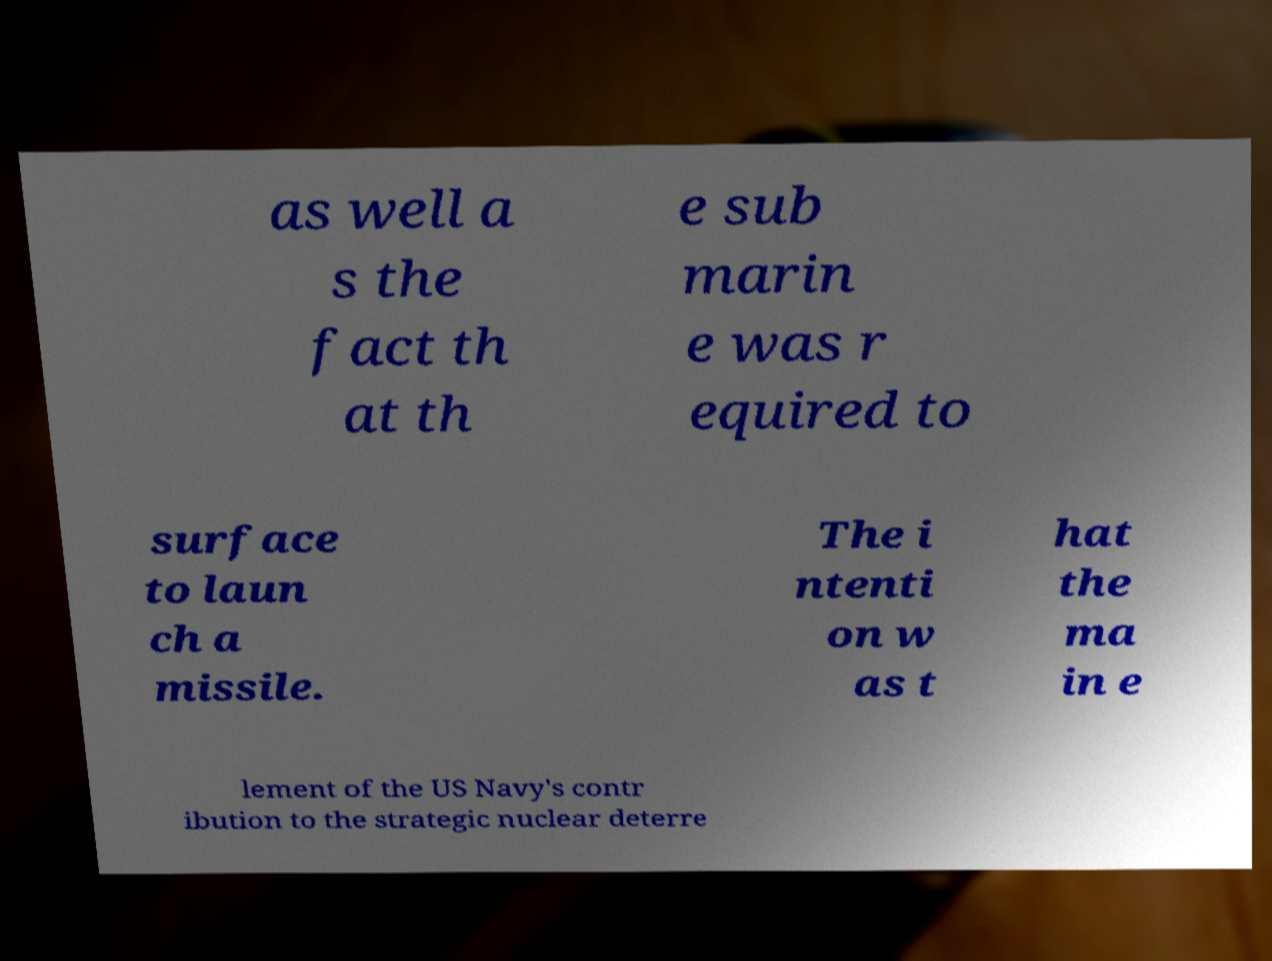Can you accurately transcribe the text from the provided image for me? as well a s the fact th at th e sub marin e was r equired to surface to laun ch a missile. The i ntenti on w as t hat the ma in e lement of the US Navy's contr ibution to the strategic nuclear deterre 